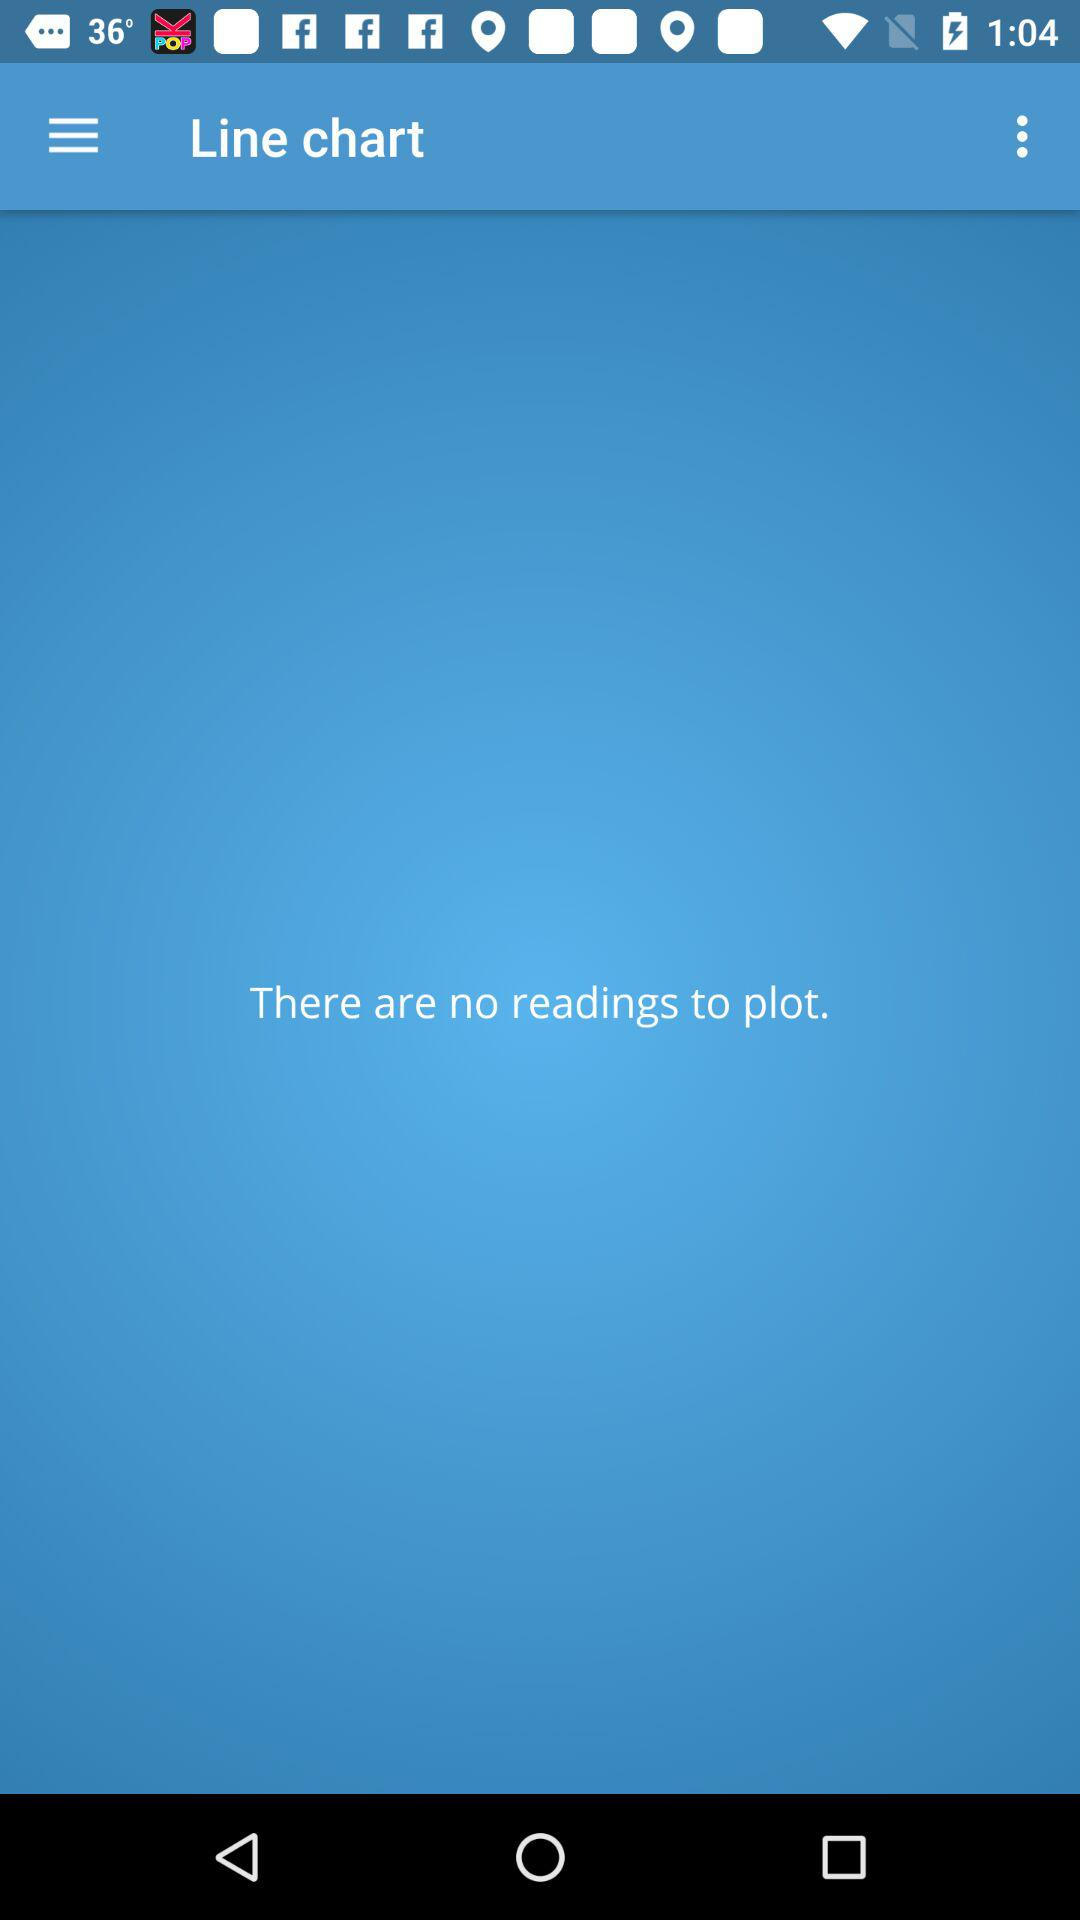Are there any readings to plot? There are no readings to plot. 